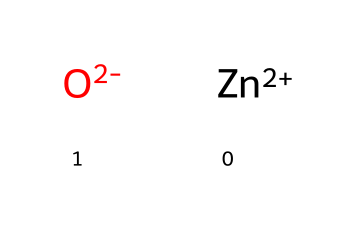What are the two elements present in this compound? The SMILES notation shows [Zn+2] indicating the presence of zinc and [O-2] indicating oxygen. Together, these denote the two elements in zinc oxide.
Answer: zinc, oxygen How many zinc atoms are in the chemical structure? The notation [Zn+2] represents one zinc atom, confirming that there is a single zinc atom in the structure.
Answer: one What type of bond exists between zinc and oxygen? In zinc oxide, zinc and oxygen are held together by an ionic bond. Zinc typically loses two electrons to form Zn^2+, while oxygen gains two electrons to form O^2-, resulting in an electrostatic attraction.
Answer: ionic What is the charge on the zinc ion in this compound? The notation [Zn+2] indicates that the zinc ion has a positive charge of +2.
Answer: +2 What is the overall charge of the zinc oxide compound? The positive charge from zinc (+2) balances with the negative charge from oxygen (-2), resulting in a neutral overall charge for the compound.
Answer: neutral Is zinc oxide soluble in water? Zinc oxide has low solubility in water, making it effective as a UV filter in sunscreen. This low solubility plays a significant role in its use for outdoor protection.
Answer: low 